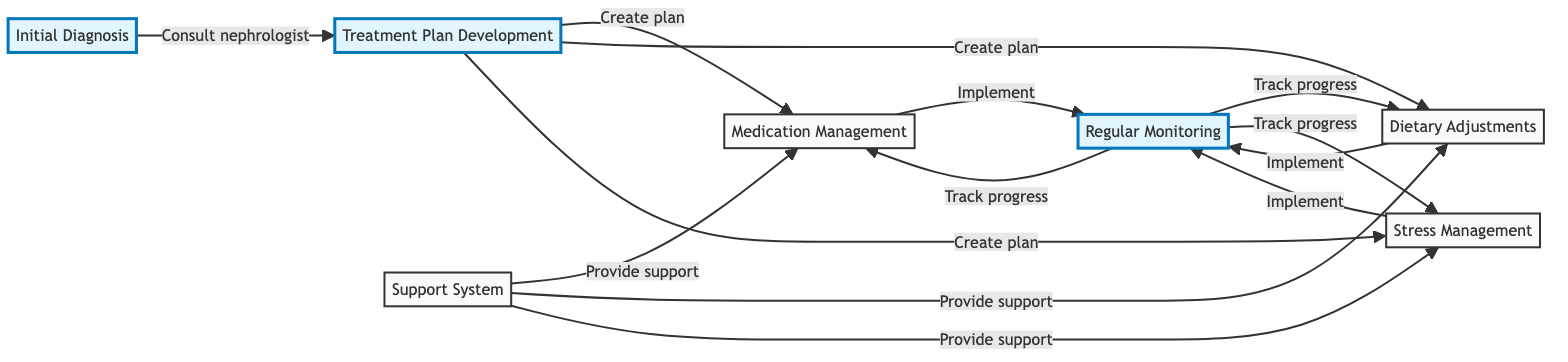What is the first step in the kidney disease management plan? The first step is "Initial Diagnosis." This is indicated at the start of the flowchart, representing the beginning of the process.
Answer: Initial Diagnosis How many main elements are in the diagram? The diagram contains a total of seven main elements, which include various steps in the kidney disease management plan.
Answer: 7 Which actors are involved in the "Medication Management"? The actors involved in "Medication Management" are the Patient and Pharmacist, as depicted in the respective node.
Answer: Patient, Pharmacist What action is associated with the "Stress Management" step? The action associated with "Stress Management" is to incorporate stress-relief techniques, which is listed within that node in the flowchart.
Answer: Incorporate stress-relief techniques Which two nodes are directly connected to the "Treatment Plan Development"? "Medication Management," "Dietary Adjustments," and "Stress Management" are directly connected to "Treatment Plan Development," showing the various areas to address after the plan is created.
Answer: Medication Management, Dietary Adjustments, Stress Management What do the arrows in the diagram represent? The arrows represent the flow of steps from one element to another, indicating the direction and sequence of the kidney disease management process.
Answer: Flow of steps Which element involves a support network? The element that involves building a support network is "Support System," as indicated by its description and connections in the diagram.
Answer: Support System What is the connection between "Regular Monitoring" and "Medication Management"? The connection indicates that "Regular Monitoring" is an action taken to track progress of "Medication Management," highlighting the importance of follow-up in this process.
Answer: Track progress In the context of the diagram, which role does a nephrologist play? The nephrologist's role is crucial, as they are involved in both the "Initial Diagnosis" and "Regular Monitoring," serving as a key healthcare provider throughout the management plan.
Answer: Healthcare provider 